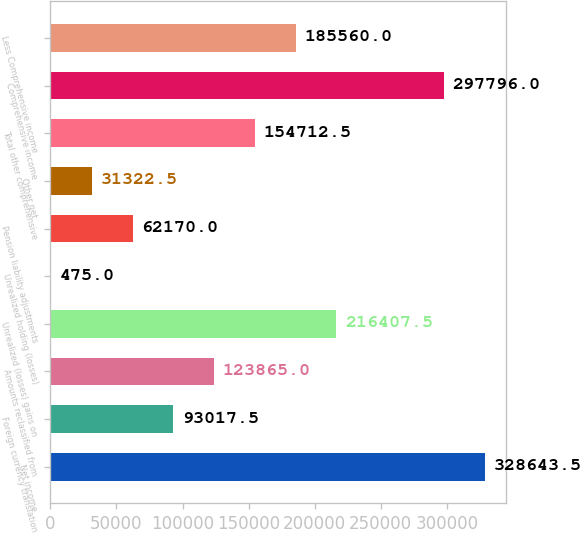<chart> <loc_0><loc_0><loc_500><loc_500><bar_chart><fcel>Net income<fcel>Foreign currency translation<fcel>Amounts reclassified from<fcel>Unrealized (losses) gains on<fcel>Unrealized holding (losses)<fcel>Pension liability adjustments<fcel>Other net<fcel>Total other comprehensive<fcel>Comprehensive income<fcel>Less Comprehensive income<nl><fcel>328644<fcel>93017.5<fcel>123865<fcel>216408<fcel>475<fcel>62170<fcel>31322.5<fcel>154712<fcel>297796<fcel>185560<nl></chart> 